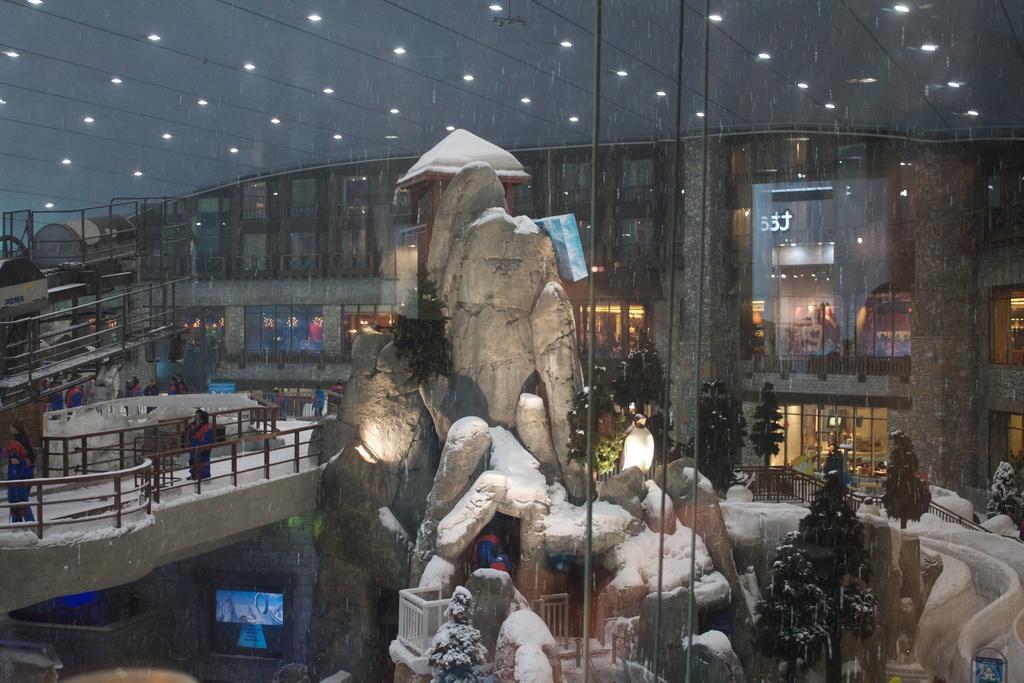Could you give a brief overview of what you see in this image? In this image there are few persons walking behind the fence. Few persons are in the cave. There are few trees. Behind there is building. Beside the rock there is a screen attached to the rock. 